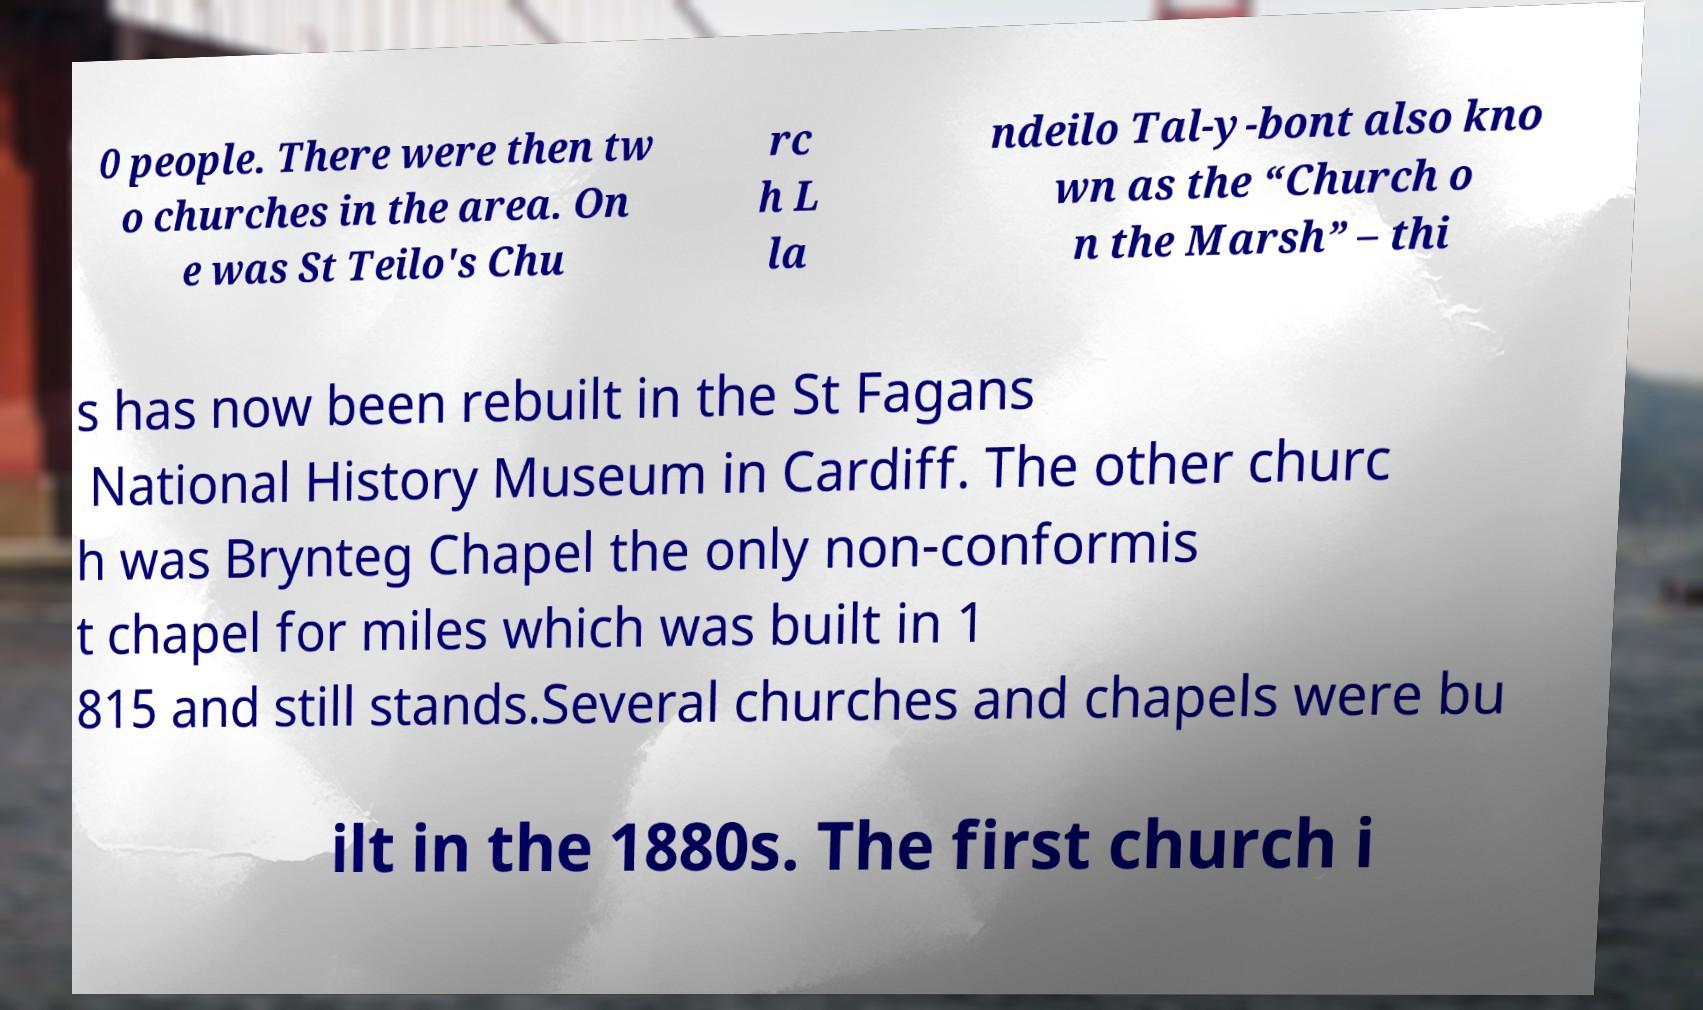What messages or text are displayed in this image? I need them in a readable, typed format. 0 people. There were then tw o churches in the area. On e was St Teilo's Chu rc h L la ndeilo Tal-y-bont also kno wn as the “Church o n the Marsh” – thi s has now been rebuilt in the St Fagans National History Museum in Cardiff. The other churc h was Brynteg Chapel the only non-conformis t chapel for miles which was built in 1 815 and still stands.Several churches and chapels were bu ilt in the 1880s. The first church i 